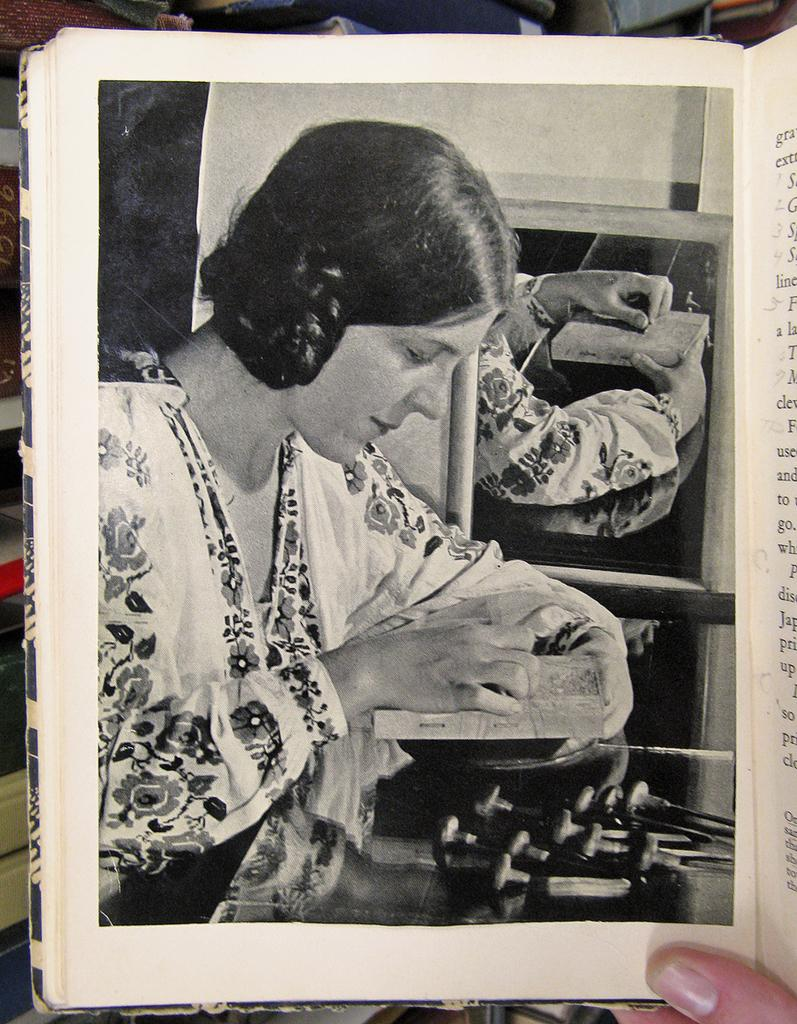What is the person in the image doing? The person in the image is holding a book. What can be found inside the book? The book contains a picture of a lady. What object in the image might be used for personal grooming or reflection? There is a mirror in the image. How many passengers are visible in the image? There are no passengers present in the image, as it only features a person holding a book. What type of curve can be seen in the image? There is no curve visible in the image. 